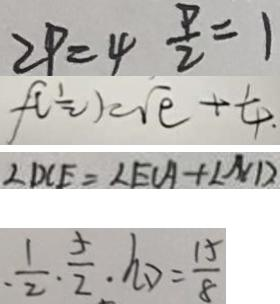Convert formula to latex. <formula><loc_0><loc_0><loc_500><loc_500>2 P = 4 \frac { P } { 2 } = 1 
 f ( \frac { 1 } { 2 } ) = \sqrt { e } + \frac { 1 } { 4 } 
 \angle D C E = \angle E C A + \angle N D 
 \cdot \frac { 1 } { 2 } \cdot \frac { 5 } { 2 } \cdot h D = \frac { 1 5 } { 8 }</formula> 